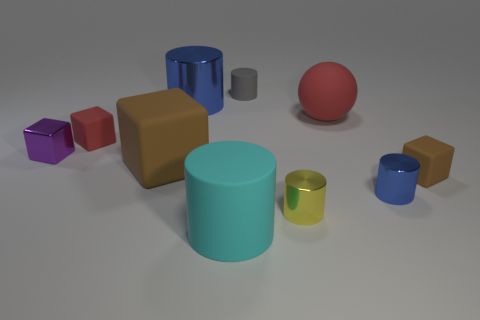What is the shape of the brown thing that is left of the brown matte thing that is on the right side of the large cylinder in front of the small purple thing? cube 